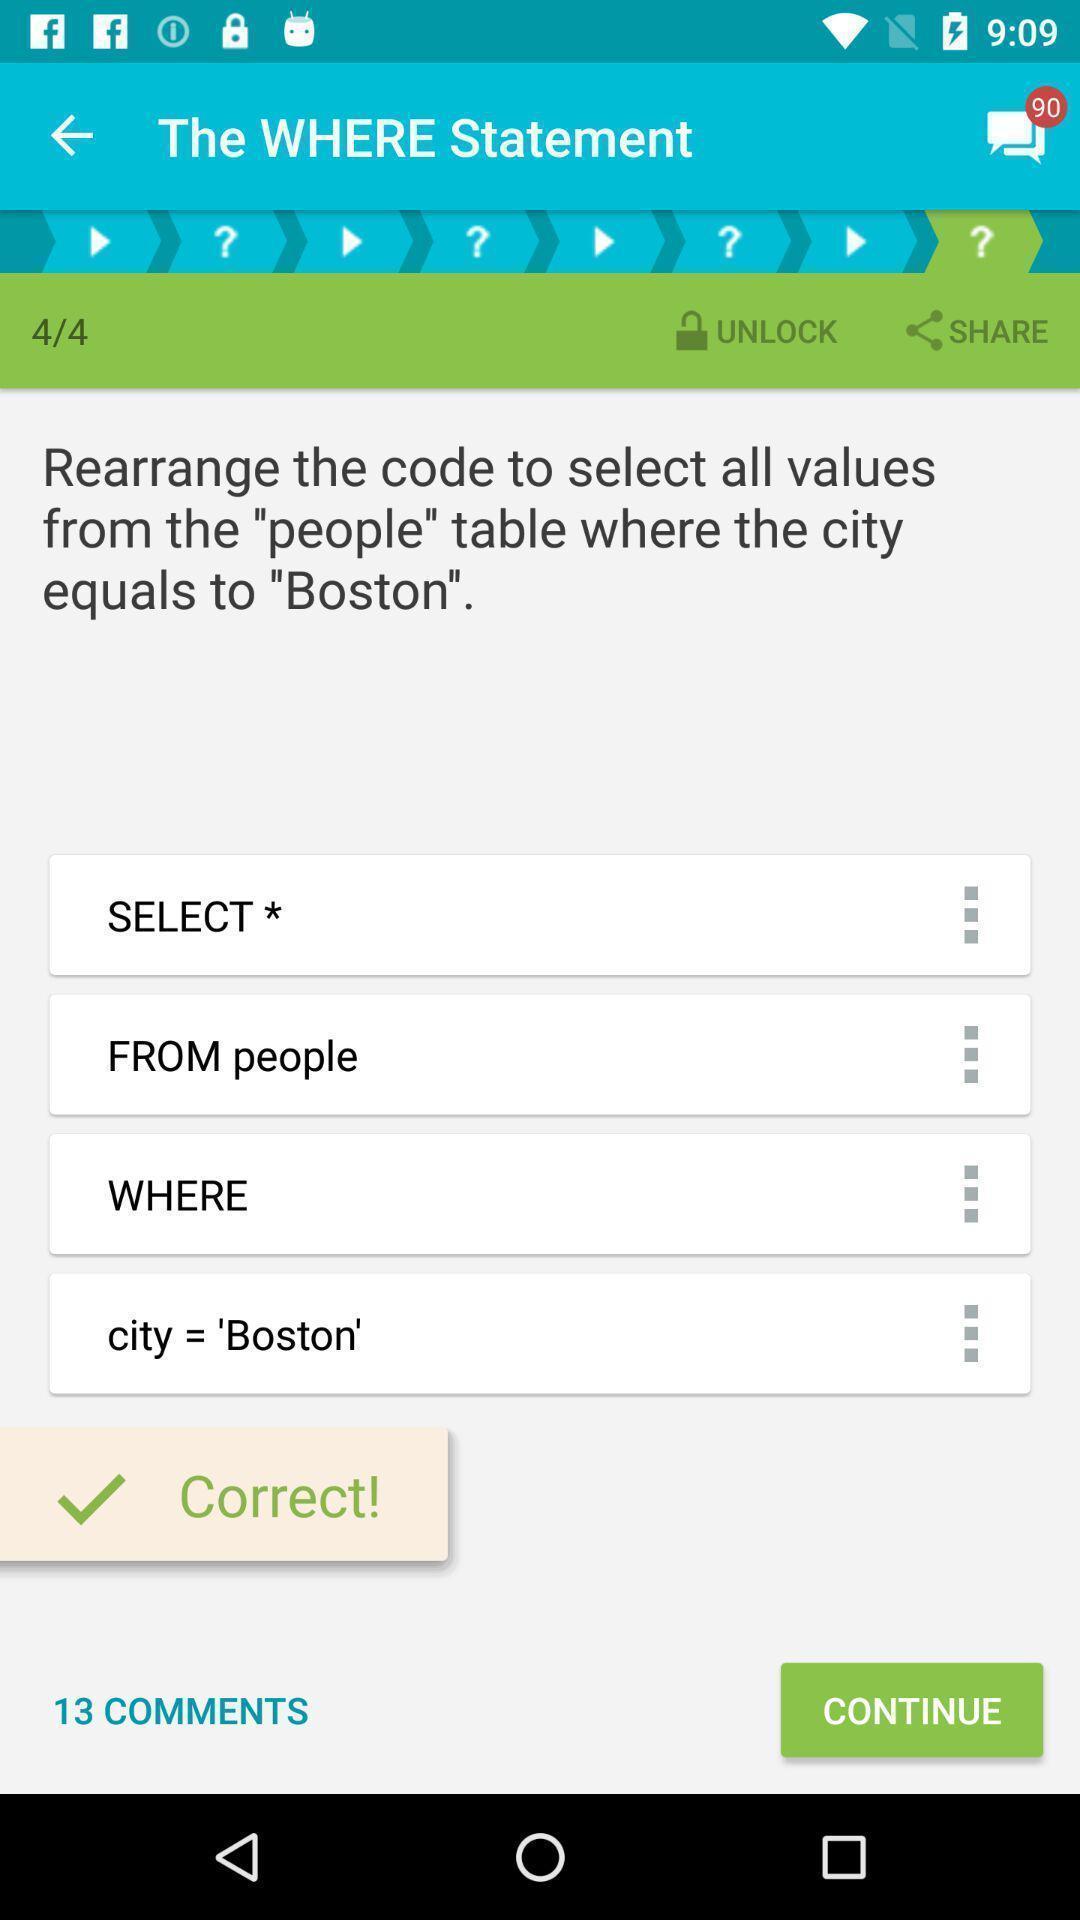What is the overall content of this screenshot? Task status page in a learning app. 